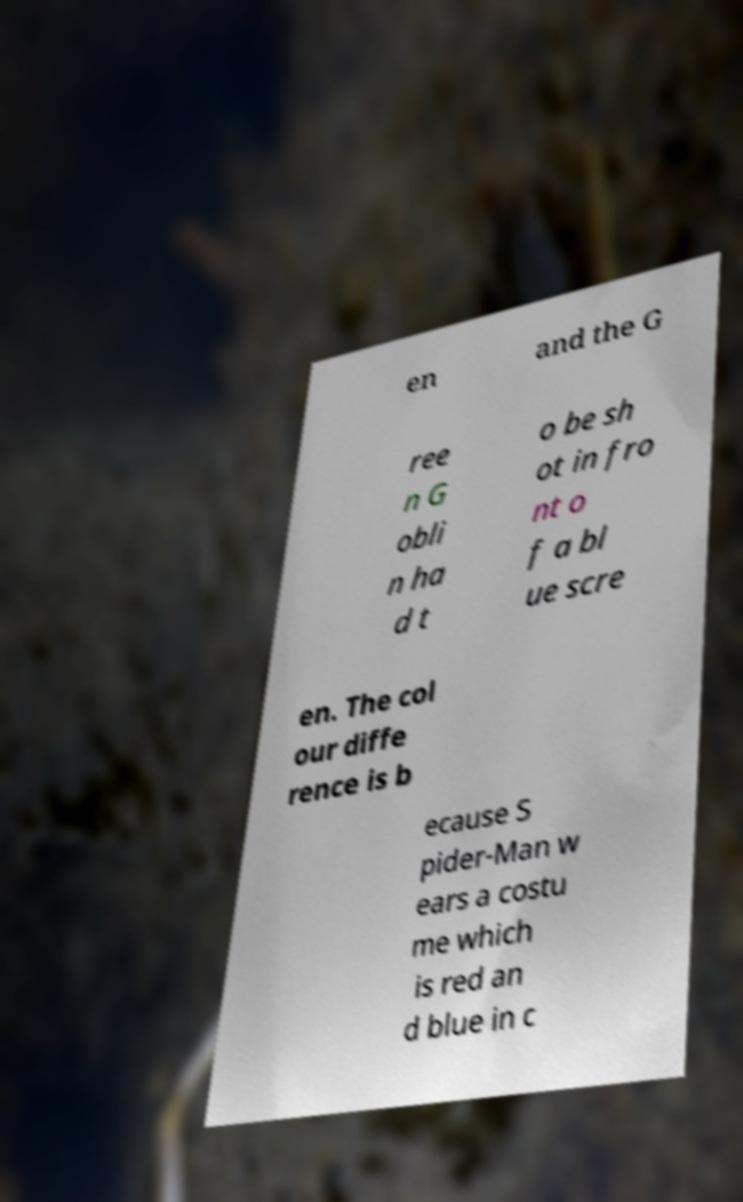What messages or text are displayed in this image? I need them in a readable, typed format. en and the G ree n G obli n ha d t o be sh ot in fro nt o f a bl ue scre en. The col our diffe rence is b ecause S pider-Man w ears a costu me which is red an d blue in c 